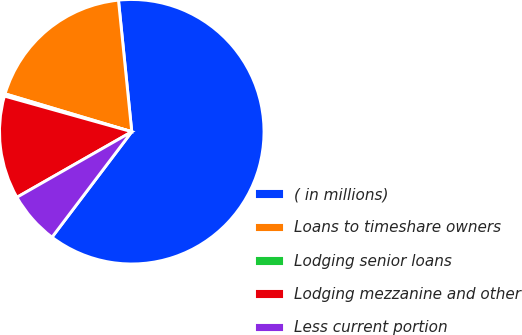<chart> <loc_0><loc_0><loc_500><loc_500><pie_chart><fcel>( in millions)<fcel>Loans to timeshare owners<fcel>Lodging senior loans<fcel>Lodging mezzanine and other<fcel>Less current portion<nl><fcel>61.91%<fcel>18.77%<fcel>0.28%<fcel>12.6%<fcel>6.44%<nl></chart> 